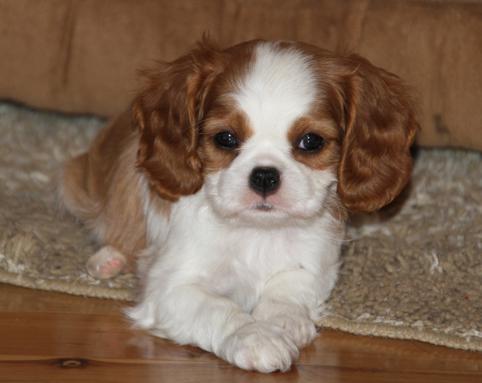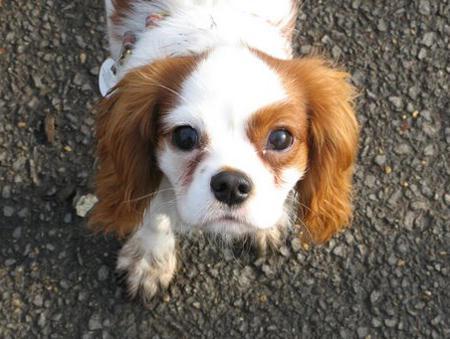The first image is the image on the left, the second image is the image on the right. Evaluate the accuracy of this statement regarding the images: "There are two dogs looking directly at the camera.". Is it true? Answer yes or no. Yes. The first image is the image on the left, the second image is the image on the right. Examine the images to the left and right. Is the description "An image shows a brown and white spaniel puppy on a varnished wood floor." accurate? Answer yes or no. Yes. 